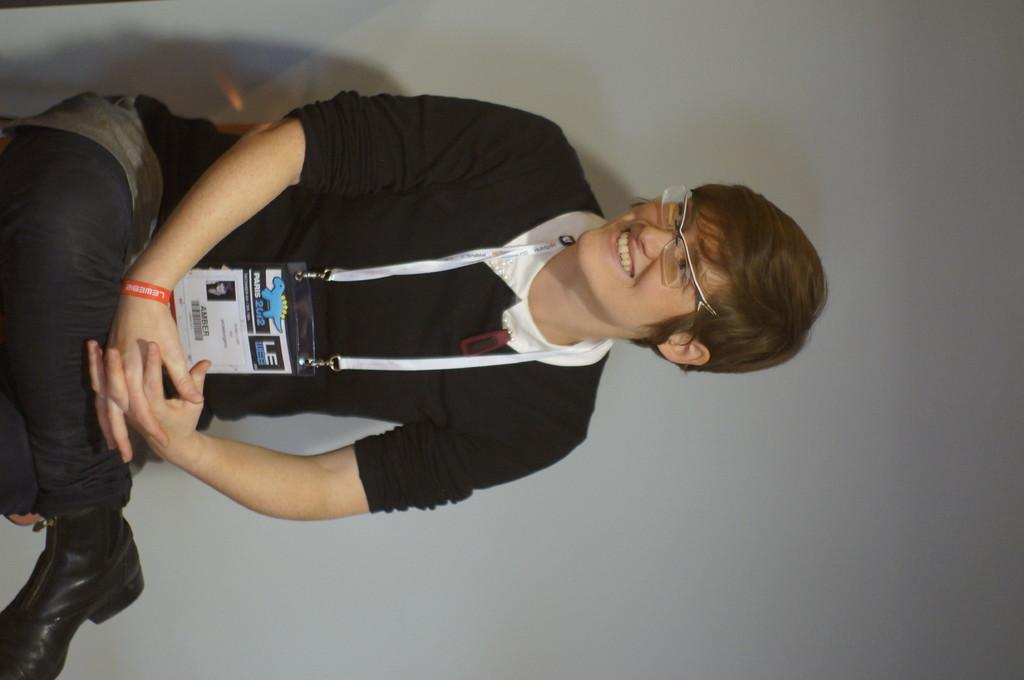Who or what is the main subject in the image? There is a person in the image. What is the person doing in the image? The person is sitting on a chair. Can you describe any accessories the person is wearing? The person is wearing spectacles. What can be seen in the background of the image? There is a wall in the background of the image. What type of chicken is the person holding in the image? There is no chicken present in the image. How old is the person's daughter in the image? There is no daughter present in the image. 